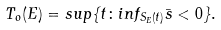<formula> <loc_0><loc_0><loc_500><loc_500>T _ { o } ( E ) = s u p \{ t \colon i n f _ { S _ { E } ( t ) } \bar { s } < 0 \} .</formula> 